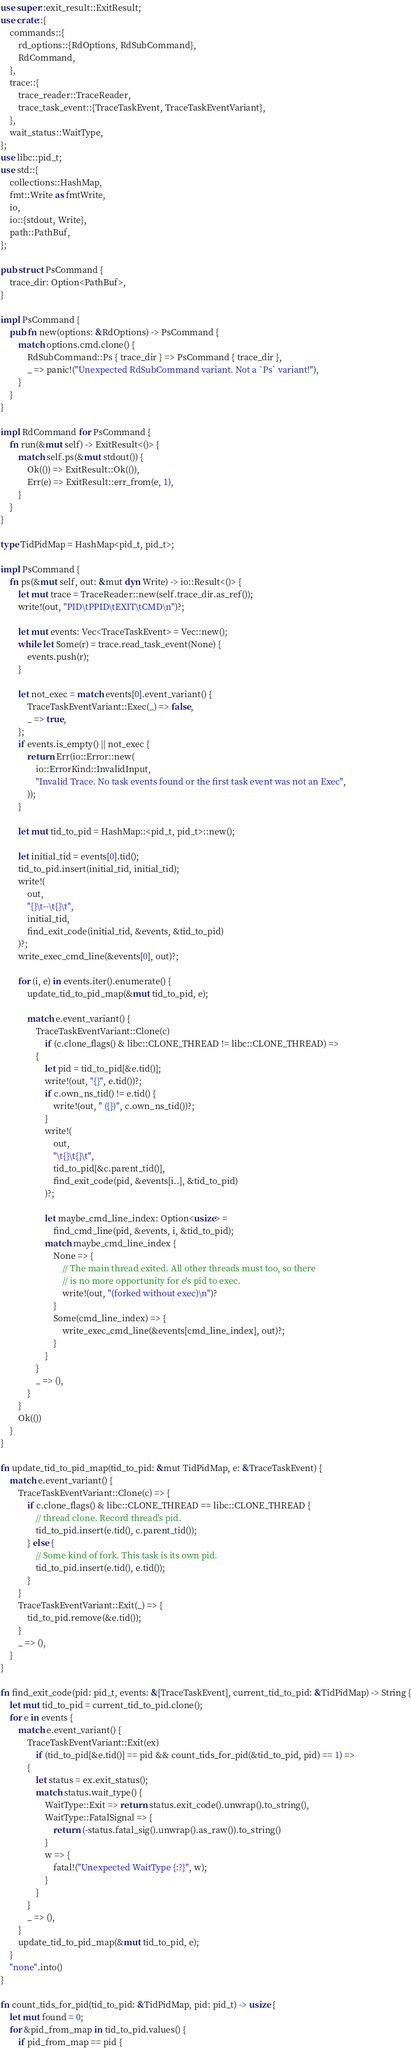Convert code to text. <code><loc_0><loc_0><loc_500><loc_500><_Rust_>use super::exit_result::ExitResult;
use crate::{
    commands::{
        rd_options::{RdOptions, RdSubCommand},
        RdCommand,
    },
    trace::{
        trace_reader::TraceReader,
        trace_task_event::{TraceTaskEvent, TraceTaskEventVariant},
    },
    wait_status::WaitType,
};
use libc::pid_t;
use std::{
    collections::HashMap,
    fmt::Write as fmtWrite,
    io,
    io::{stdout, Write},
    path::PathBuf,
};

pub struct PsCommand {
    trace_dir: Option<PathBuf>,
}

impl PsCommand {
    pub fn new(options: &RdOptions) -> PsCommand {
        match options.cmd.clone() {
            RdSubCommand::Ps { trace_dir } => PsCommand { trace_dir },
            _ => panic!("Unexpected RdSubCommand variant. Not a `Ps` variant!"),
        }
    }
}

impl RdCommand for PsCommand {
    fn run(&mut self) -> ExitResult<()> {
        match self.ps(&mut stdout()) {
            Ok(()) => ExitResult::Ok(()),
            Err(e) => ExitResult::err_from(e, 1),
        }
    }
}

type TidPidMap = HashMap<pid_t, pid_t>;

impl PsCommand {
    fn ps(&mut self, out: &mut dyn Write) -> io::Result<()> {
        let mut trace = TraceReader::new(self.trace_dir.as_ref());
        write!(out, "PID\tPPID\tEXIT\tCMD\n")?;

        let mut events: Vec<TraceTaskEvent> = Vec::new();
        while let Some(r) = trace.read_task_event(None) {
            events.push(r);
        }

        let not_exec = match events[0].event_variant() {
            TraceTaskEventVariant::Exec(_) => false,
            _ => true,
        };
        if events.is_empty() || not_exec {
            return Err(io::Error::new(
                io::ErrorKind::InvalidInput,
                "Invalid Trace. No task events found or the first task event was not an Exec",
            ));
        }

        let mut tid_to_pid = HashMap::<pid_t, pid_t>::new();

        let initial_tid = events[0].tid();
        tid_to_pid.insert(initial_tid, initial_tid);
        write!(
            out,
            "{}\t--\t{}\t",
            initial_tid,
            find_exit_code(initial_tid, &events, &tid_to_pid)
        )?;
        write_exec_cmd_line(&events[0], out)?;

        for (i, e) in events.iter().enumerate() {
            update_tid_to_pid_map(&mut tid_to_pid, e);

            match e.event_variant() {
                TraceTaskEventVariant::Clone(c)
                    if (c.clone_flags() & libc::CLONE_THREAD != libc::CLONE_THREAD) =>
                {
                    let pid = tid_to_pid[&e.tid()];
                    write!(out, "{}", e.tid())?;
                    if c.own_ns_tid() != e.tid() {
                        write!(out, " ({})", c.own_ns_tid())?;
                    }
                    write!(
                        out,
                        "\t{}\t{}\t",
                        tid_to_pid[&c.parent_tid()],
                        find_exit_code(pid, &events[i..], &tid_to_pid)
                    )?;

                    let maybe_cmd_line_index: Option<usize> =
                        find_cmd_line(pid, &events, i, &tid_to_pid);
                    match maybe_cmd_line_index {
                        None => {
                            // The main thread exited. All other threads must too, so there
                            // is no more opportunity for e's pid to exec.
                            write!(out, "(forked without exec)\n")?
                        }
                        Some(cmd_line_index) => {
                            write_exec_cmd_line(&events[cmd_line_index], out)?;
                        }
                    }
                }
                _ => (),
            }
        }
        Ok(())
    }
}

fn update_tid_to_pid_map(tid_to_pid: &mut TidPidMap, e: &TraceTaskEvent) {
    match e.event_variant() {
        TraceTaskEventVariant::Clone(c) => {
            if c.clone_flags() & libc::CLONE_THREAD == libc::CLONE_THREAD {
                // thread clone. Record thread's pid.
                tid_to_pid.insert(e.tid(), c.parent_tid());
            } else {
                // Some kind of fork. This task is its own pid.
                tid_to_pid.insert(e.tid(), e.tid());
            }
        }
        TraceTaskEventVariant::Exit(_) => {
            tid_to_pid.remove(&e.tid());
        }
        _ => (),
    }
}

fn find_exit_code(pid: pid_t, events: &[TraceTaskEvent], current_tid_to_pid: &TidPidMap) -> String {
    let mut tid_to_pid = current_tid_to_pid.clone();
    for e in events {
        match e.event_variant() {
            TraceTaskEventVariant::Exit(ex)
                if (tid_to_pid[&e.tid()] == pid && count_tids_for_pid(&tid_to_pid, pid) == 1) =>
            {
                let status = ex.exit_status();
                match status.wait_type() {
                    WaitType::Exit => return status.exit_code().unwrap().to_string(),
                    WaitType::FatalSignal => {
                        return (-status.fatal_sig().unwrap().as_raw()).to_string()
                    }
                    w => {
                        fatal!("Unexpected WaitType {:?}", w);
                    }
                }
            }
            _ => (),
        }
        update_tid_to_pid_map(&mut tid_to_pid, e);
    }
    "none".into()
}

fn count_tids_for_pid(tid_to_pid: &TidPidMap, pid: pid_t) -> usize {
    let mut found = 0;
    for &pid_from_map in tid_to_pid.values() {
        if pid_from_map == pid {</code> 